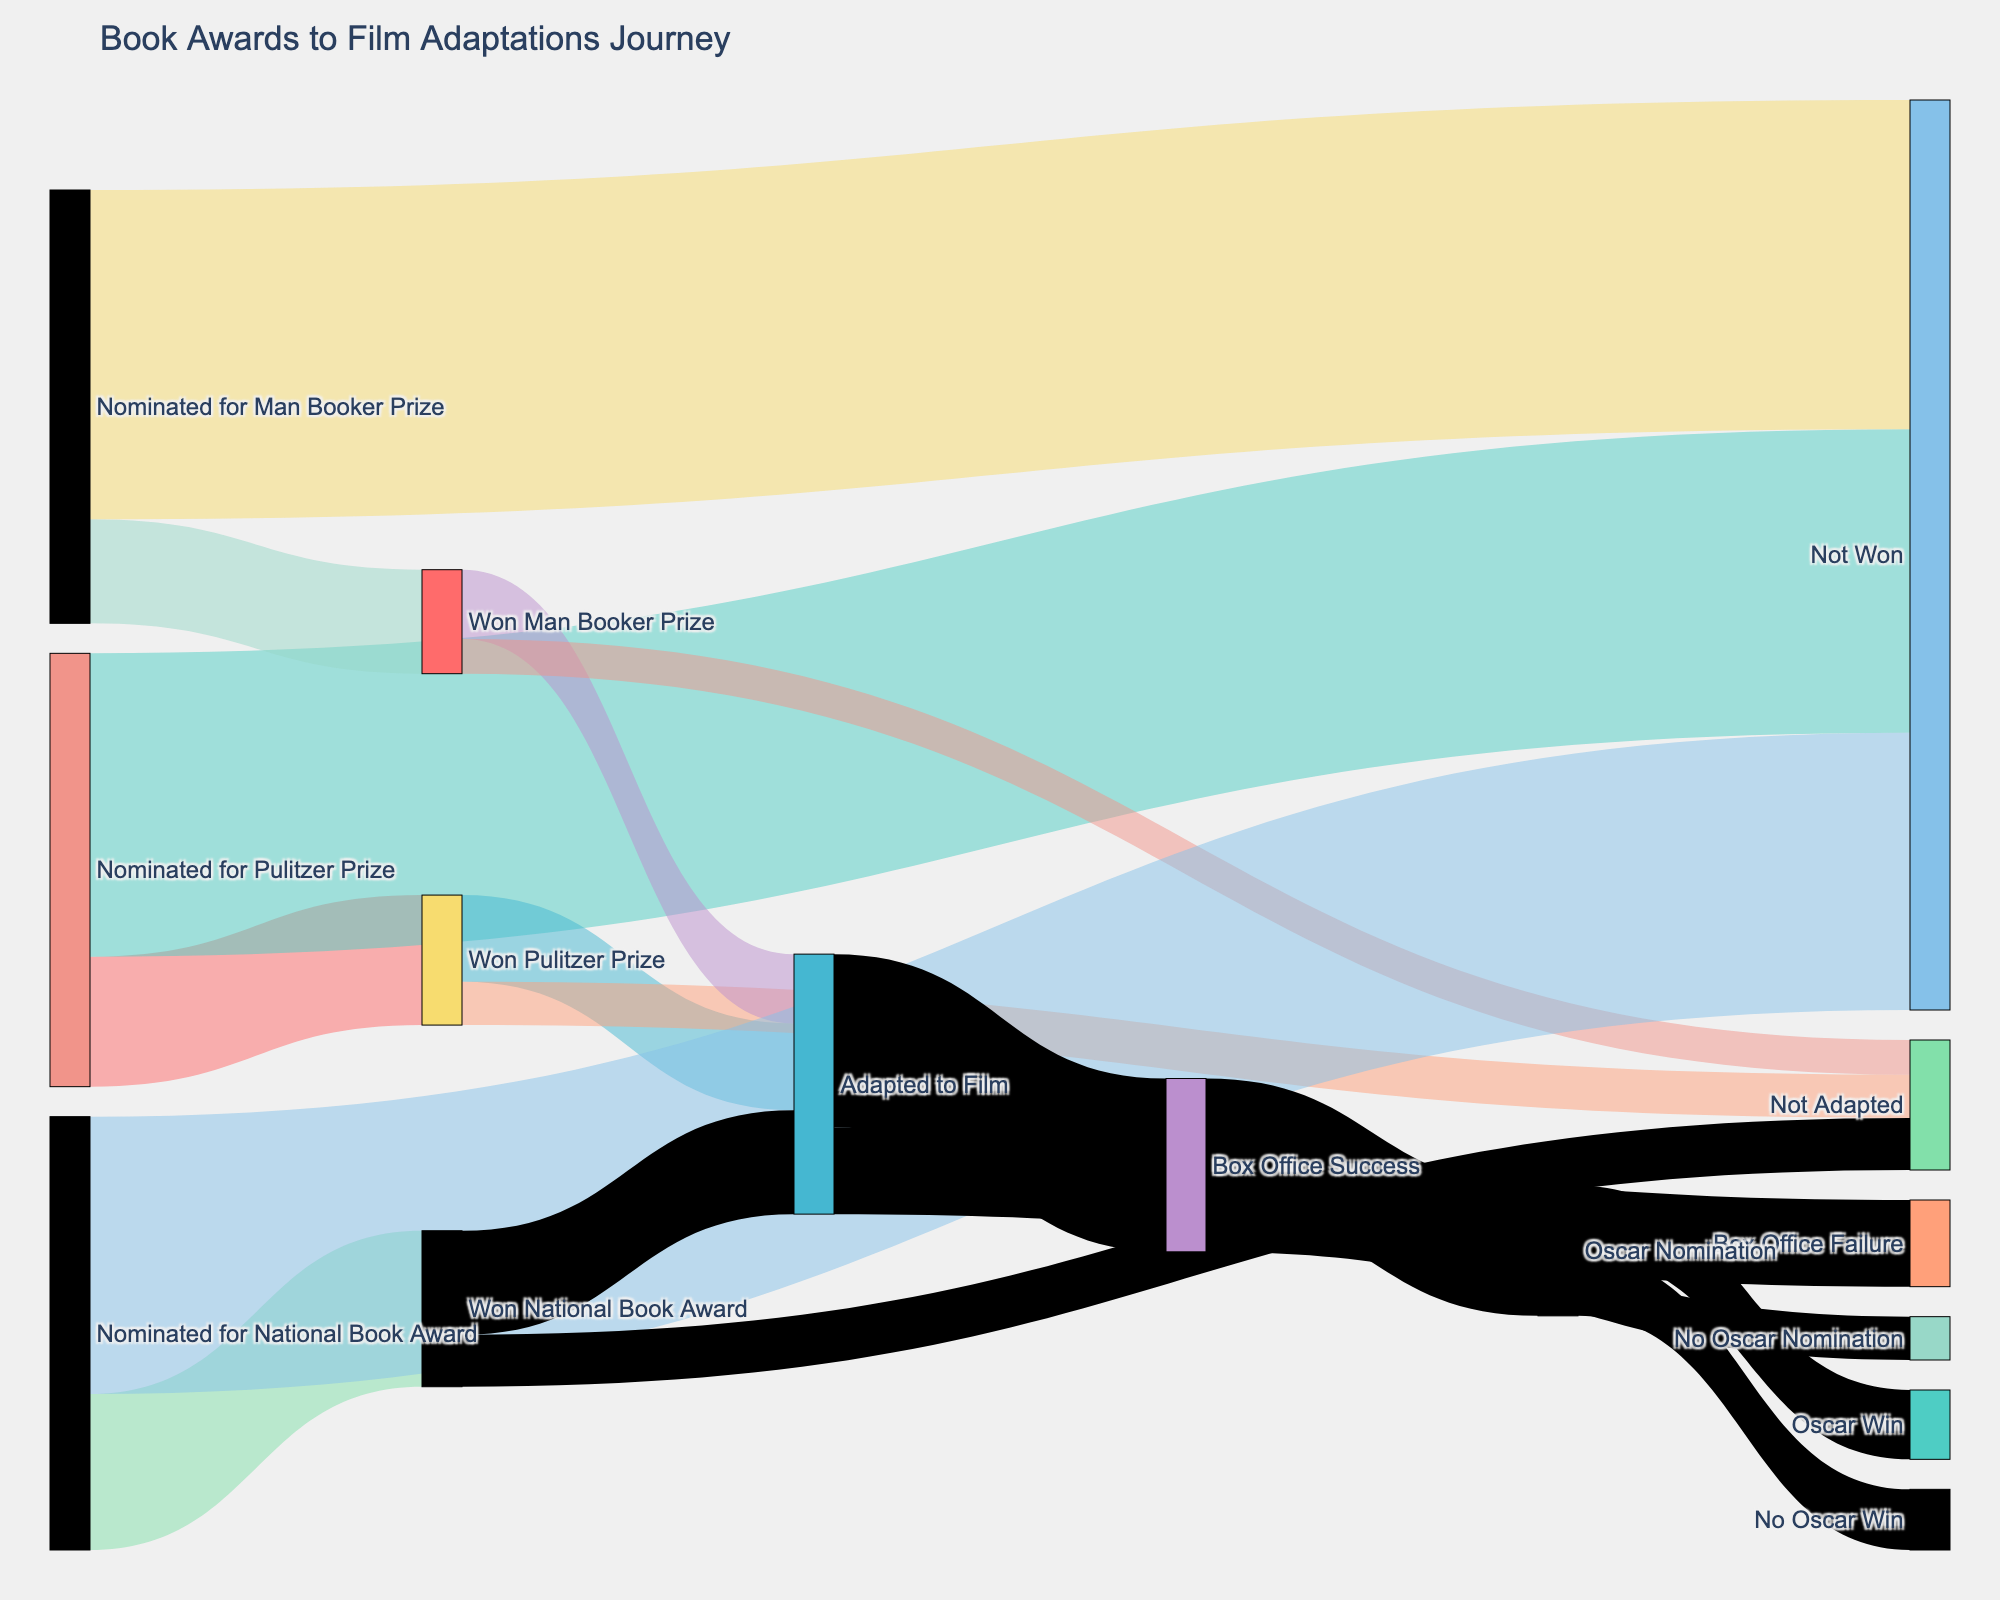How many books that won the Pulitzer Prize were adapted into films? We see that 10 books which won the Pulitzer Prize proceeded to the "Adapted to Film" stage. This is visualized by the flow moving from "Won Pulitzer Prize" to "Adapted to Film" with a value of 10.
Answer: 10 How many total nominations were there for the Man Booker Prize? By adding the counts from "Nominated for Man Booker Prize" to both "Won Man Booker Prize" and "Not Won", the total nominations are 12 + 38.
Answer: 50 Which prize had the highest number of films adapted from winning books? By comparing the flow from "Won Pulitzer Prize" to "Adapted to Film" (10), "Won Man Booker Prize" to "Adapted to Film" (8), and "Won National Book Award" to "Adapted to Film" (12), we see the National Book Award had the highest.
Answer: National Book Award How many films adapted from book awards were considered a box office success? We examine the flows from "Adapted to Film" to either "Box Office Success" or "Box Office Failure", noting "Box Office Success" has a value of 20.
Answer: 20 What proportion of Pulitzer Prize-winning books were not adapted into films? The values leading from "Won Pulitzer Prize" to "Not Adapted" (5) must be considered against the total Pulitzer winners (10 + 5). The fraction is 5 out of 15, which simplifies to 1/3.
Answer: 1/3 How many books that won a National Book Award ended up as films? The flow from "Won National Book Award" to "Adapted to Film" shows 12 books were adapted into films.
Answer: 12 How many Oscar wins occurred from films that were box office successes? The relevant flow from "Box Office Success" to "Oscar Win" is valued at 8.
Answer: 8 How many more films adapted from books were a success at the box office compared to failures? By comparing the flow values for "Box Office Success" (20) and "Box Office Failure" (10), the calculation is 20 - 10 = 10.
Answer: 10 How many nominations did the National Book Award have? Adding the flows from "Nominated for National Book Award" to both "Won National Book Award" and "Not Won" gives 18 + 32.
Answer: 50 What is the success rate of films that won an Oscar when nominated? The flow from "Oscar Nomination" to "Oscar Win" (8) and "No Oscar Win" (7) indicates nominations are 15. The rate is 8/15 or roughly 53%.
Answer: 53% 